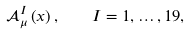Convert formula to latex. <formula><loc_0><loc_0><loc_500><loc_500>\mathcal { A } _ { \mu } ^ { I } \left ( x \right ) , \quad I = 1 , \dots , 1 9 ,</formula> 